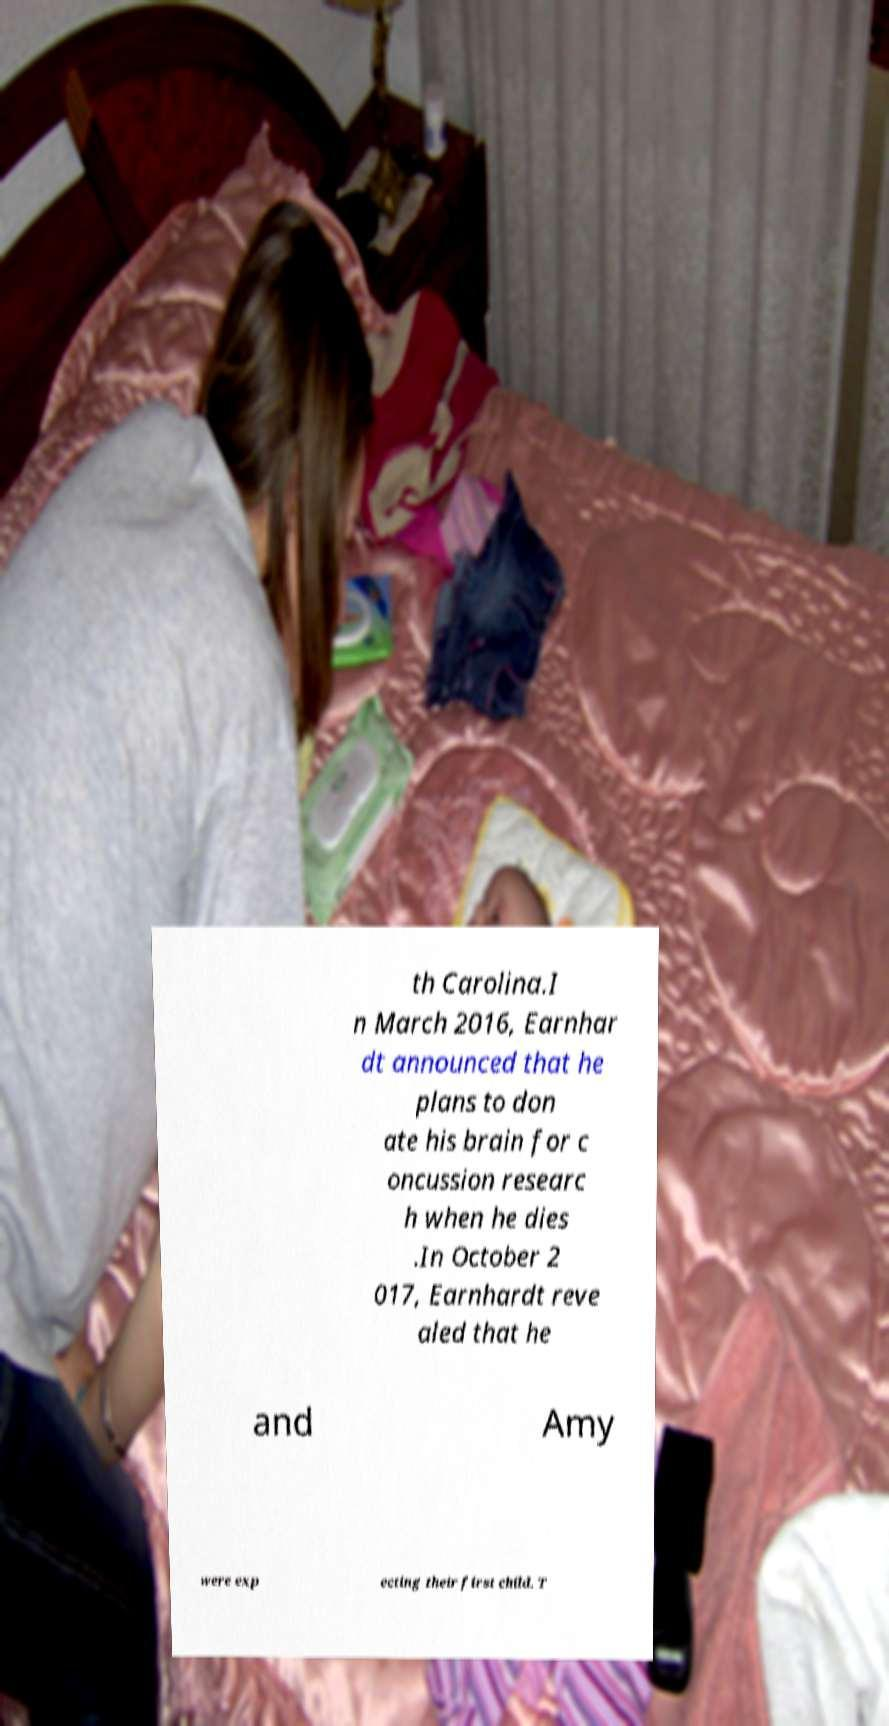Can you accurately transcribe the text from the provided image for me? th Carolina.I n March 2016, Earnhar dt announced that he plans to don ate his brain for c oncussion researc h when he dies .In October 2 017, Earnhardt reve aled that he and Amy were exp ecting their first child. T 